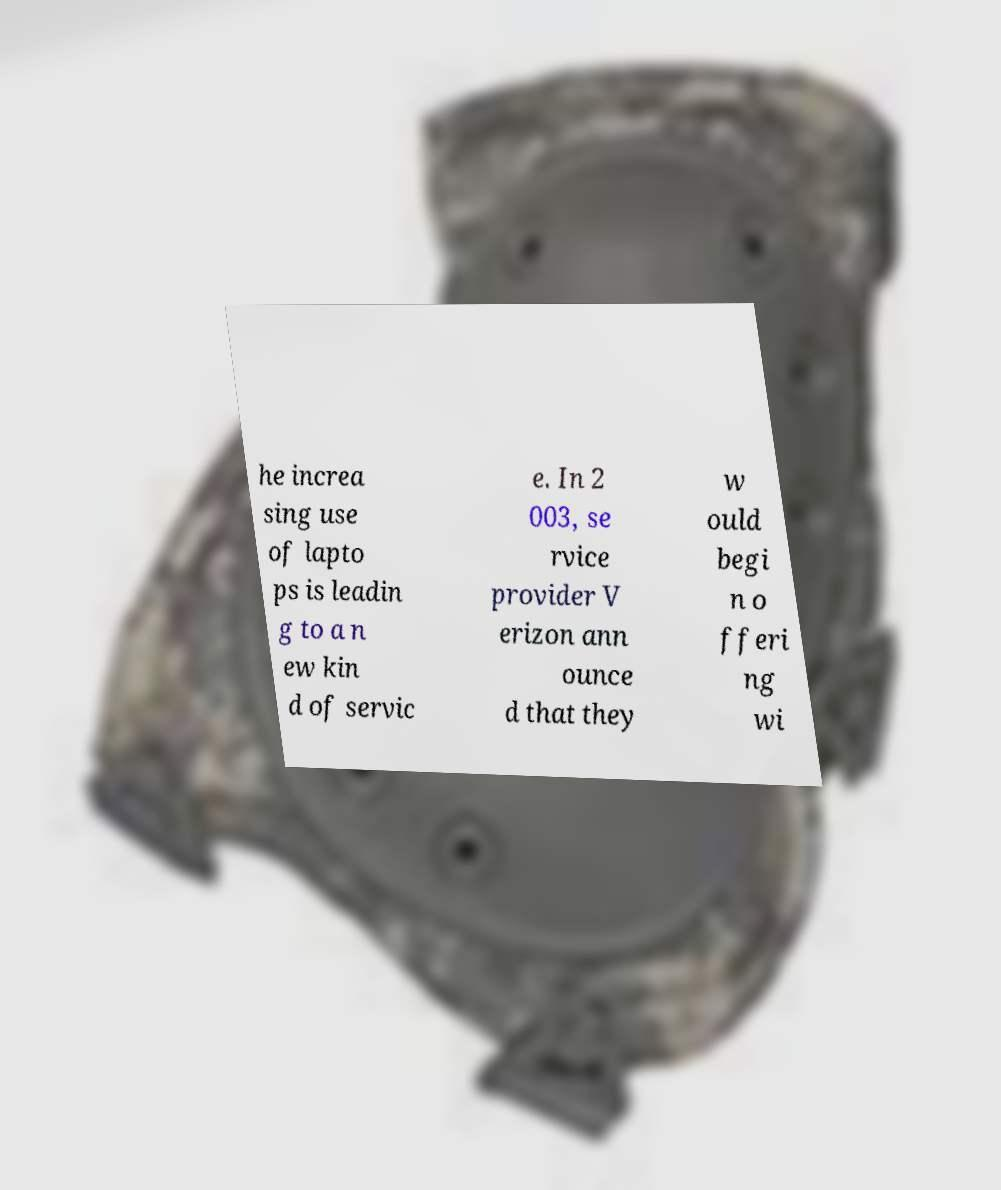For documentation purposes, I need the text within this image transcribed. Could you provide that? he increa sing use of lapto ps is leadin g to a n ew kin d of servic e. In 2 003, se rvice provider V erizon ann ounce d that they w ould begi n o fferi ng wi 